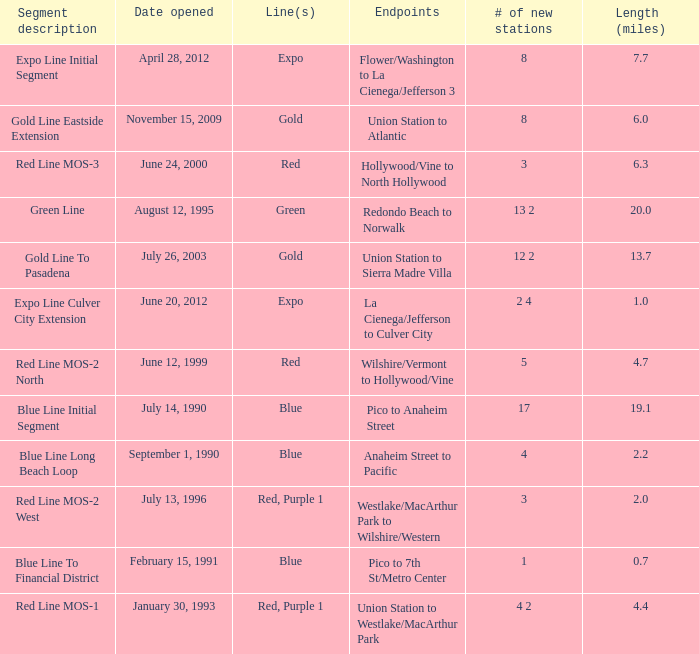How many news stations opened on the date of June 24, 2000? 3.0. 